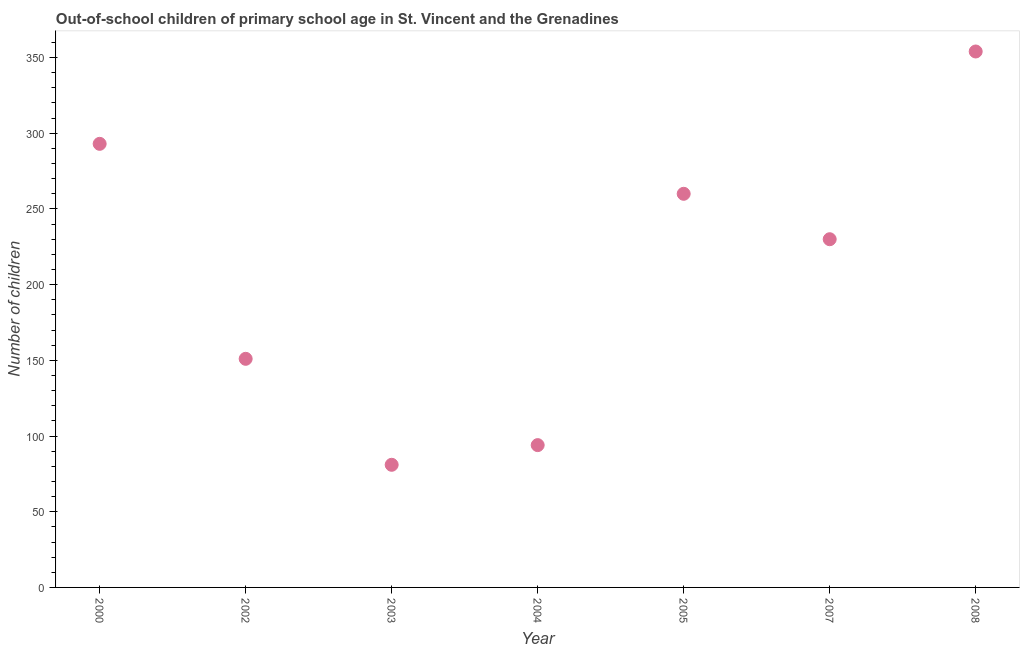What is the number of out-of-school children in 2005?
Give a very brief answer. 260. Across all years, what is the maximum number of out-of-school children?
Give a very brief answer. 354. Across all years, what is the minimum number of out-of-school children?
Provide a short and direct response. 81. In which year was the number of out-of-school children maximum?
Give a very brief answer. 2008. What is the sum of the number of out-of-school children?
Your response must be concise. 1463. What is the difference between the number of out-of-school children in 2002 and 2004?
Ensure brevity in your answer.  57. What is the average number of out-of-school children per year?
Provide a succinct answer. 209. What is the median number of out-of-school children?
Offer a terse response. 230. What is the ratio of the number of out-of-school children in 2004 to that in 2008?
Offer a terse response. 0.27. Is the number of out-of-school children in 2002 less than that in 2004?
Give a very brief answer. No. What is the difference between the highest and the second highest number of out-of-school children?
Offer a terse response. 61. Is the sum of the number of out-of-school children in 2003 and 2008 greater than the maximum number of out-of-school children across all years?
Provide a short and direct response. Yes. What is the difference between the highest and the lowest number of out-of-school children?
Your answer should be very brief. 273. In how many years, is the number of out-of-school children greater than the average number of out-of-school children taken over all years?
Your answer should be compact. 4. How many dotlines are there?
Offer a very short reply. 1. What is the difference between two consecutive major ticks on the Y-axis?
Your answer should be very brief. 50. Are the values on the major ticks of Y-axis written in scientific E-notation?
Make the answer very short. No. Does the graph contain any zero values?
Keep it short and to the point. No. What is the title of the graph?
Ensure brevity in your answer.  Out-of-school children of primary school age in St. Vincent and the Grenadines. What is the label or title of the X-axis?
Your answer should be very brief. Year. What is the label or title of the Y-axis?
Offer a very short reply. Number of children. What is the Number of children in 2000?
Make the answer very short. 293. What is the Number of children in 2002?
Provide a succinct answer. 151. What is the Number of children in 2004?
Your answer should be compact. 94. What is the Number of children in 2005?
Ensure brevity in your answer.  260. What is the Number of children in 2007?
Provide a short and direct response. 230. What is the Number of children in 2008?
Provide a succinct answer. 354. What is the difference between the Number of children in 2000 and 2002?
Your answer should be compact. 142. What is the difference between the Number of children in 2000 and 2003?
Offer a terse response. 212. What is the difference between the Number of children in 2000 and 2004?
Make the answer very short. 199. What is the difference between the Number of children in 2000 and 2008?
Offer a terse response. -61. What is the difference between the Number of children in 2002 and 2003?
Ensure brevity in your answer.  70. What is the difference between the Number of children in 2002 and 2005?
Your response must be concise. -109. What is the difference between the Number of children in 2002 and 2007?
Your answer should be compact. -79. What is the difference between the Number of children in 2002 and 2008?
Your answer should be very brief. -203. What is the difference between the Number of children in 2003 and 2004?
Provide a succinct answer. -13. What is the difference between the Number of children in 2003 and 2005?
Keep it short and to the point. -179. What is the difference between the Number of children in 2003 and 2007?
Offer a very short reply. -149. What is the difference between the Number of children in 2003 and 2008?
Make the answer very short. -273. What is the difference between the Number of children in 2004 and 2005?
Offer a very short reply. -166. What is the difference between the Number of children in 2004 and 2007?
Make the answer very short. -136. What is the difference between the Number of children in 2004 and 2008?
Make the answer very short. -260. What is the difference between the Number of children in 2005 and 2008?
Offer a terse response. -94. What is the difference between the Number of children in 2007 and 2008?
Give a very brief answer. -124. What is the ratio of the Number of children in 2000 to that in 2002?
Provide a short and direct response. 1.94. What is the ratio of the Number of children in 2000 to that in 2003?
Ensure brevity in your answer.  3.62. What is the ratio of the Number of children in 2000 to that in 2004?
Provide a succinct answer. 3.12. What is the ratio of the Number of children in 2000 to that in 2005?
Ensure brevity in your answer.  1.13. What is the ratio of the Number of children in 2000 to that in 2007?
Provide a succinct answer. 1.27. What is the ratio of the Number of children in 2000 to that in 2008?
Provide a succinct answer. 0.83. What is the ratio of the Number of children in 2002 to that in 2003?
Keep it short and to the point. 1.86. What is the ratio of the Number of children in 2002 to that in 2004?
Provide a short and direct response. 1.61. What is the ratio of the Number of children in 2002 to that in 2005?
Provide a succinct answer. 0.58. What is the ratio of the Number of children in 2002 to that in 2007?
Ensure brevity in your answer.  0.66. What is the ratio of the Number of children in 2002 to that in 2008?
Your response must be concise. 0.43. What is the ratio of the Number of children in 2003 to that in 2004?
Your answer should be compact. 0.86. What is the ratio of the Number of children in 2003 to that in 2005?
Offer a very short reply. 0.31. What is the ratio of the Number of children in 2003 to that in 2007?
Ensure brevity in your answer.  0.35. What is the ratio of the Number of children in 2003 to that in 2008?
Your response must be concise. 0.23. What is the ratio of the Number of children in 2004 to that in 2005?
Your response must be concise. 0.36. What is the ratio of the Number of children in 2004 to that in 2007?
Ensure brevity in your answer.  0.41. What is the ratio of the Number of children in 2004 to that in 2008?
Make the answer very short. 0.27. What is the ratio of the Number of children in 2005 to that in 2007?
Ensure brevity in your answer.  1.13. What is the ratio of the Number of children in 2005 to that in 2008?
Make the answer very short. 0.73. What is the ratio of the Number of children in 2007 to that in 2008?
Your answer should be very brief. 0.65. 